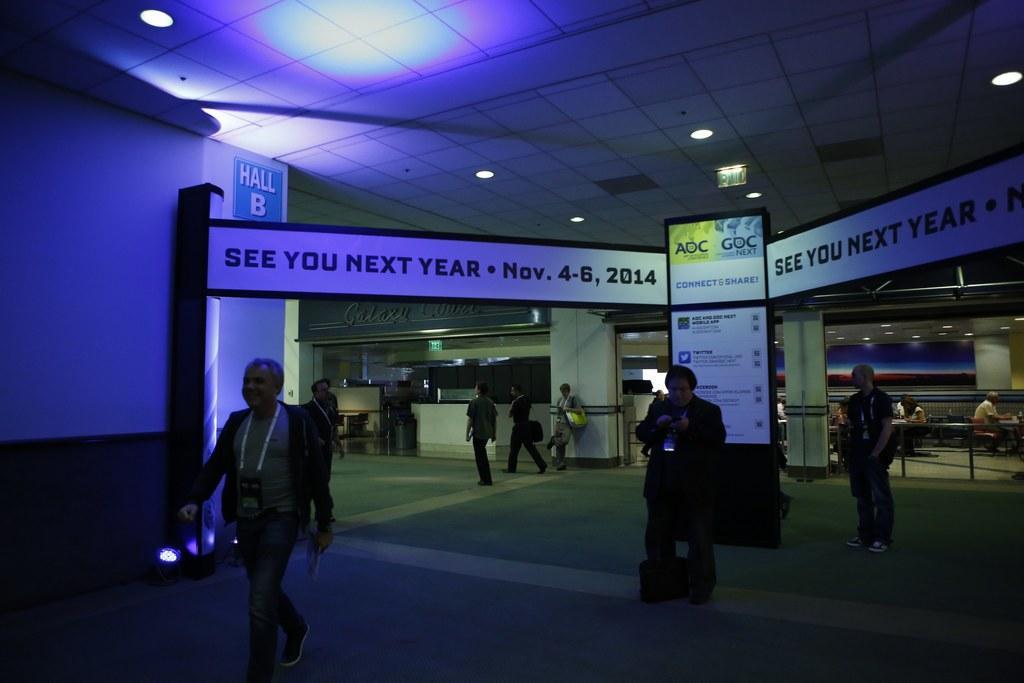Please provide a concise description of this image. In the image there are many people walking on the floor, in the middle there is a banner, on the right side there are few people sitting in front of the table and there are lights over the ceiling, this seems to be clicked in a mall. 